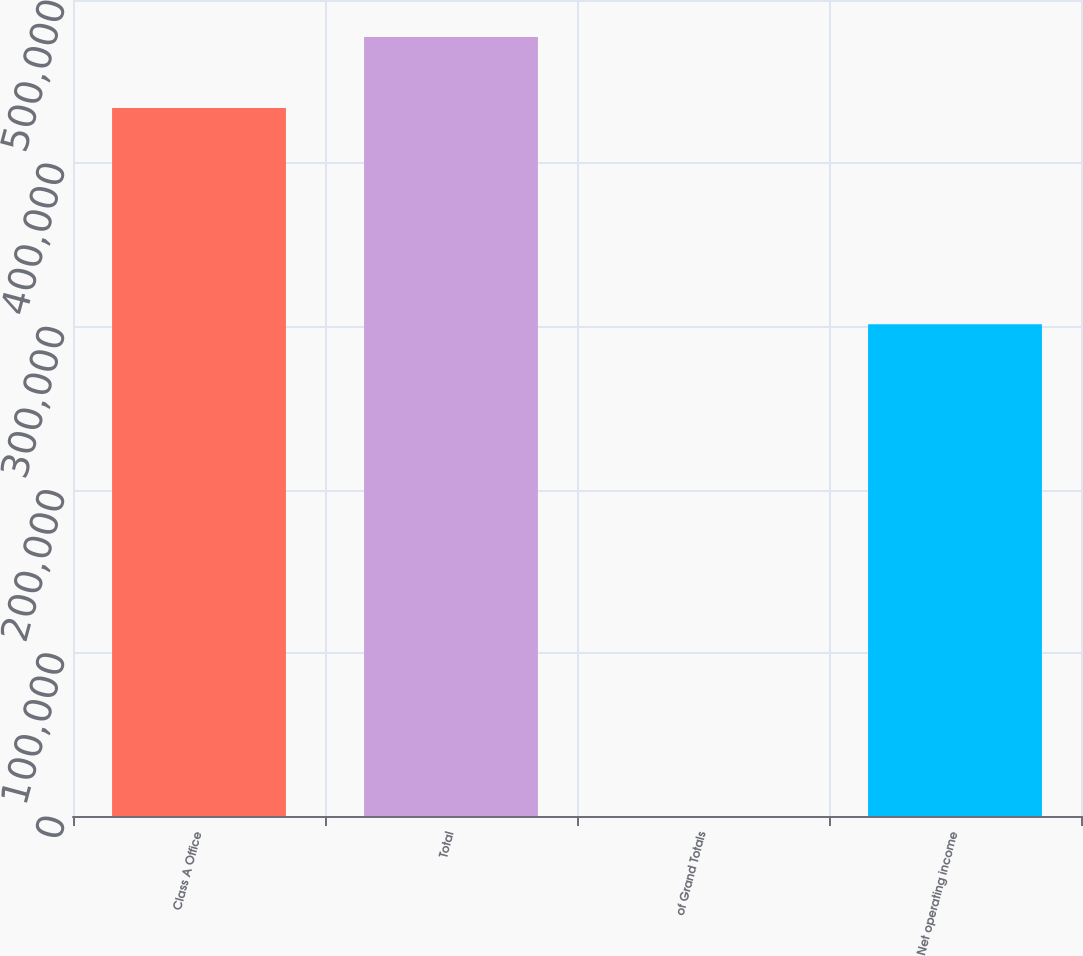Convert chart. <chart><loc_0><loc_0><loc_500><loc_500><bar_chart><fcel>Class A Office<fcel>Total<fcel>of Grand Totals<fcel>Net operating income<nl><fcel>433875<fcel>477259<fcel>34.36<fcel>301383<nl></chart> 